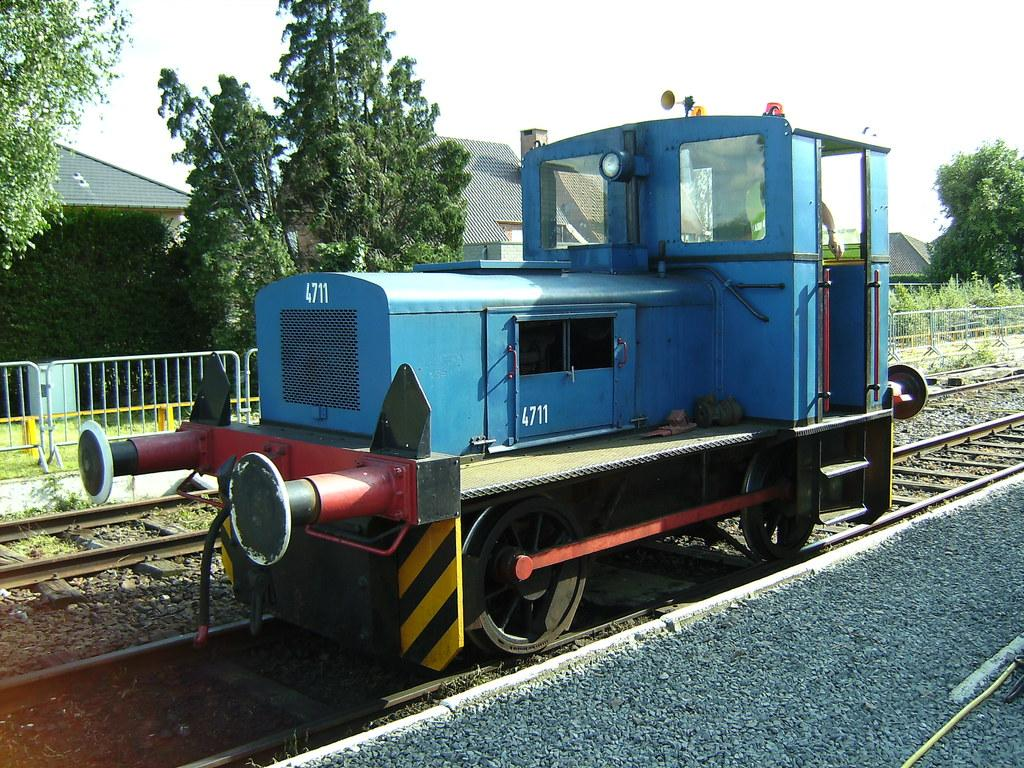What is the main subject of the image? The main subject of the image is a train engine. What color is the train engine? The train engine is blue in color. Where is the train engine located in the image? The train engine is on a track. What can be seen in the background of the image? There are trees and houses in the background of the image. How much money is hanging from the train engine in the image? There is no money hanging from the train engine in the image. What type of cobweb can be seen on the train engine in the image? There is no cobweb present on the train engine in the image. 